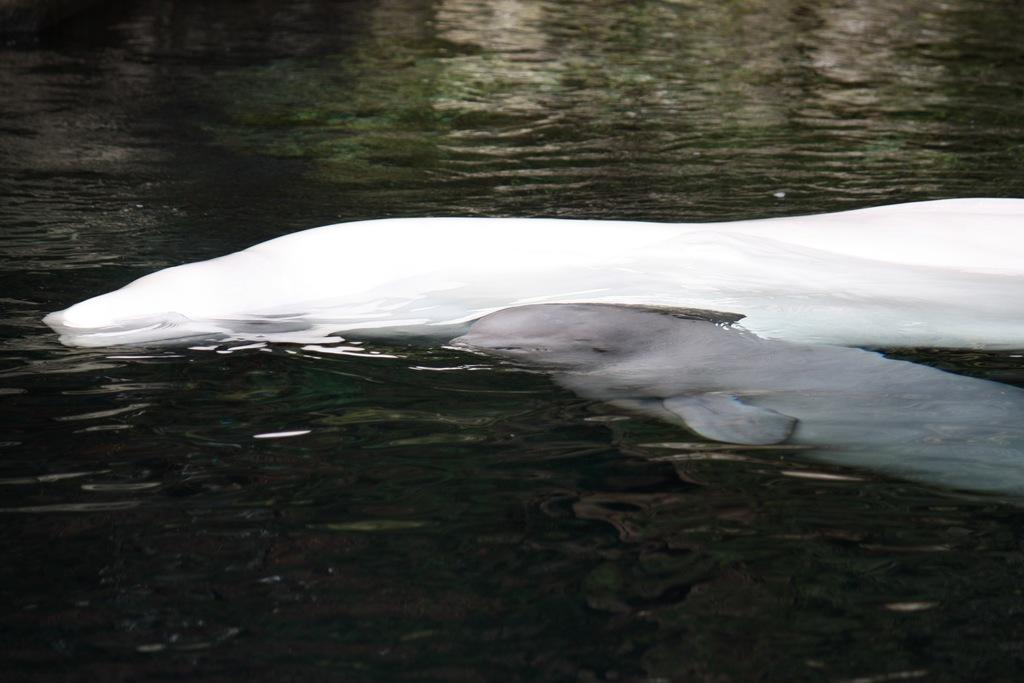What animals are present in the image? There are two dolphins in the image. Where are the dolphins located? The dolphins are in the water. What type of steam can be seen rising from the dolphins in the image? There is no steam present in the image, as it features dolphins in the water. 